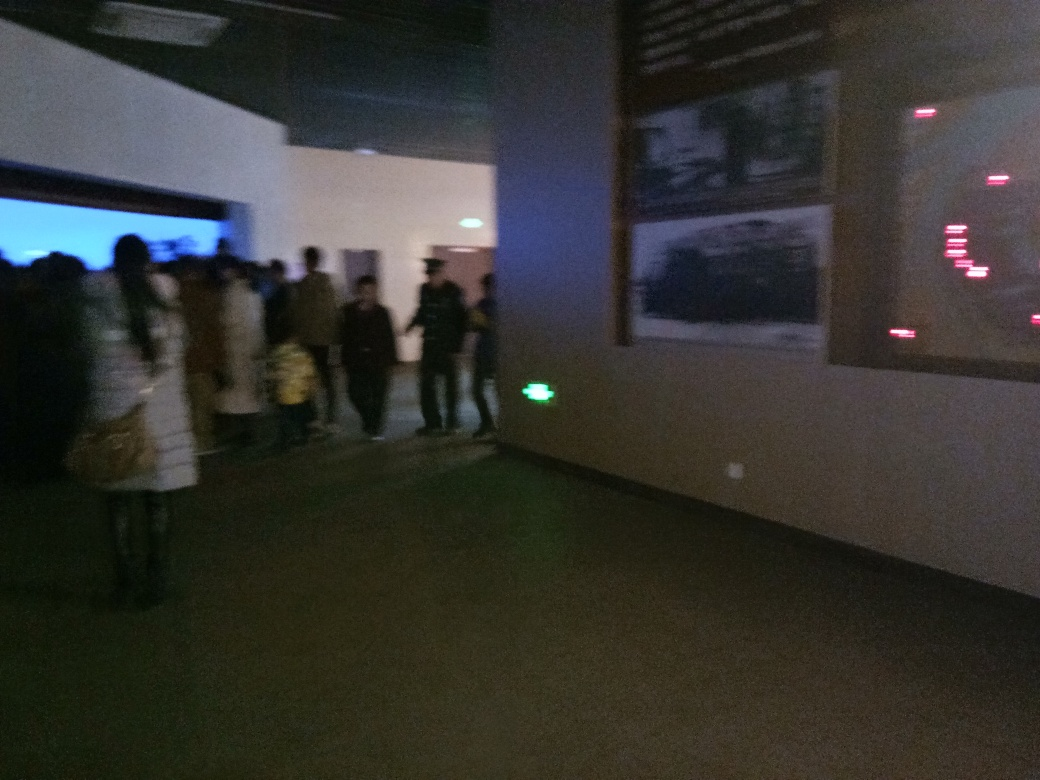What happened to the texture details of the pedestrians? The texture details of the pedestrians are obscured due to the low resolution and poor lighting conditions in the image, making it difficult to discern fine details such as facial features or clothing textures. 